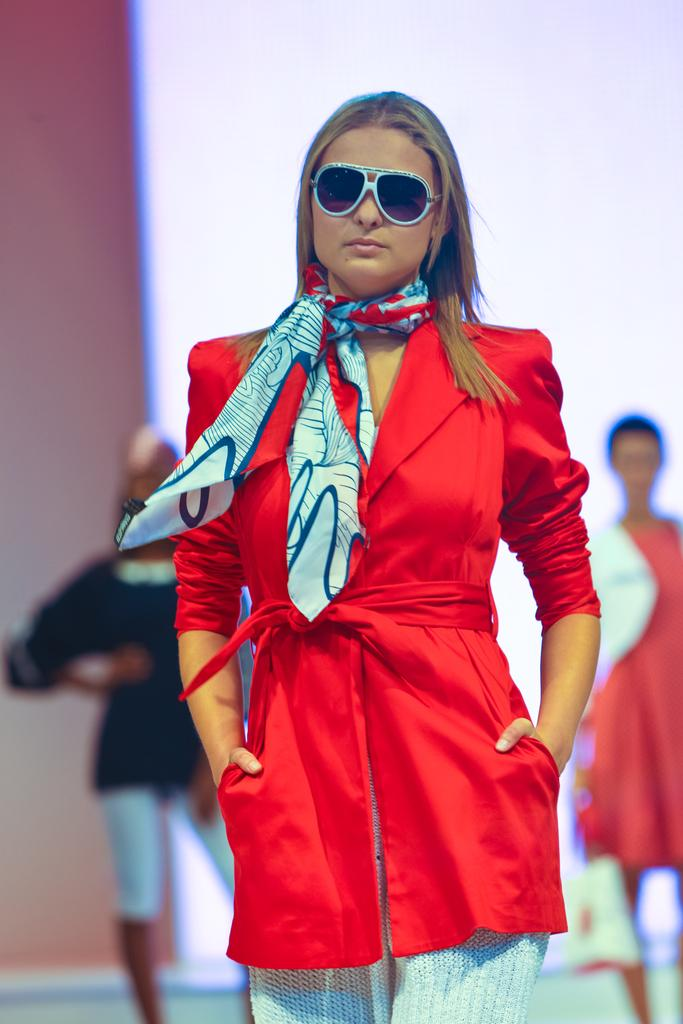Who is the main subject in the image? There is a woman in the image. What is the woman wearing? The woman is wearing a red dress. What is the woman doing in the image? The woman is standing. Can you describe the other people in the image? There are two other persons in the background of the image. What type of disgust can be seen on the woman's face in the image? There is no indication of disgust on the woman's face in the image. How many pieces of lumber are visible in the image? There is no lumber present in the image. 